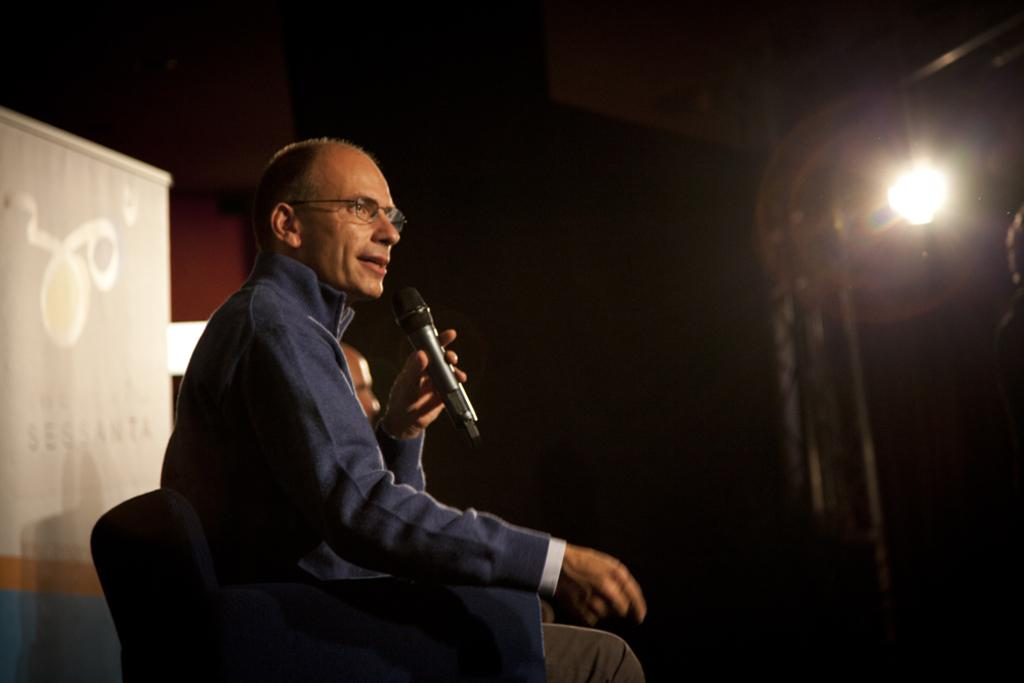Who is the main subject in the image? There is a man in the image. What is the man doing in the image? The man is sitting in a chair and speaking. What object is the man holding in his hand? The man is holding a microphone in his hand. What can be seen in the background of the image? There is a light in the background of the image. Can you see any windows in the image? There is no mention of a window in the image; only a light can be seen in the background. 